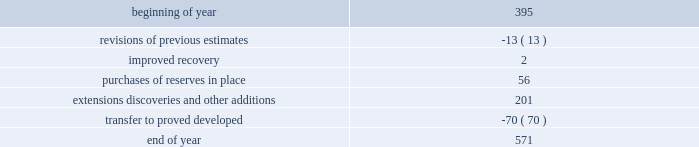Estimates of synthetic crude oil reserves are prepared by glj petroleum consultants of calgary , canada , third-party consultants .
Their reports for all years are filed as exhibits to this annual report on form 10-k .
The team lead responsible for the estimates of our osm reserves has 34 years of experience in petroleum engineering and has conducted surface mineable oil sands evaluations since 1986 .
He is a member of spe , having served as regional director from 1998 through 2001 .
The second team member has 13 years of experience in petroleum engineering and has conducted surface mineable oil sands evaluations since 2009 .
Both are registered practicing professional engineers in the province of alberta .
Audits of estimates third-party consultants are engaged to provide independent estimates for fields that comprise 80 percent of our total proved reserves over a rolling four-year period for the purpose of auditing the in-house reserve estimates .
We met this goal for the four- year period ended december 31 , 2012 .
We established a tolerance level of 10 percent such that initial estimates by the third-party consultants are accepted if they are within 10 percent of our internal estimates .
Should the third-party consultants 2019 initial analysis fail to reach our tolerance level , both our team and the consultants re-examine the information provided , request additional data and refine their analysis if appropriate .
This resolution process is continued until both estimates are within 10 percent .
In the very limited instances where differences outside the 10 percent tolerance cannot be resolved by year end , a plan to resolve the difference is developed and our senior management is informed .
This process did not result in significant changes to our reserve estimates in 2012 or 2011 .
There were no third-party audits performed in 2010 .
During 2012 , netherland , sewell & associates , inc .
( "nsai" ) prepared a certification of december 31 , 2011 reserves for the alba field in e.g .
The nsai summary report is filed as an exhibit to this annual report on form 10-k .
Members of the nsai team have many years of industry experience , having worked for large , international oil and gas companies before joining nsai .
The senior technical advisor has a bachelor of science degree in geophysics and over 15 years of experience in the estimation of and evaluation of reserves .
The second member has a bachelor of science degree in chemical engineering and master of business administration along with over 3 years of experience in estimation and evaluation of reserves .
Both are licensed in the state of texas .
Ryder scott company ( "ryder scott" ) performed audits of several of our fields in 2012 and 2011 .
Their summary reports on audits performed in 2012 and 2011 are filed as exhibits to this annual report on form 10-k .
The team lead for ryder scott has over 20 years of industry experience , having worked for a major international oil and gas company before joining ryder scott .
He has a bachelor of science degree in mechanical engineering , is a member of spe where he served on the oil and gas reserves committee and is a registered professional engineer in the state of texas .
Changes in proved undeveloped reserves as of december 31 , 2012 , 571 mmboe of proved undeveloped reserves were reported , an increase of 176 mmboe from december 31 , 2011 .
The table shows changes in total proved undeveloped reserves for 2012 : ( mmboe ) .
Significant additions to proved undeveloped reserves during 2012 include 56 mmboe due to acquisitions in the eagle ford shale .
Development drilling added 124 mmboe in the eagle ford , 35 mmboe in the bakken and 15 mmboe in the oklahoma resource basins shale play .
A gas sharing agreement signed with the libyan government in 2012 added 19 mmboe .
Additionally , 30 mmboe were transferred from proved undeveloped to proved developed reserves in the eagle ford and 14 mmboe in the bakken shale plays due to producing wells .
Costs incurred in 2012 , 2011 and 2010 relating to the development of proved undeveloped reserves , were $ 1995 million $ 1107 million and $ 1463 million .
A total of 27 mmboe was booked as a result of reliable technology .
Technologies included statistical analysis of production performance , decline curve analysis , rate transient analysis , reservoir simulation and volumetric analysis .
The statistical nature of production performance coupled with highly certain reservoir continuity or quality within the reliable technology areas and sufficient proved undeveloped locations establish the reasonable certainty criteria required for booking reserves. .
By how much did undeveloped reserves increase during 2012? 
Computations: ((571 - 395) / 395)
Answer: 0.44557. Estimates of synthetic crude oil reserves are prepared by glj petroleum consultants of calgary , canada , third-party consultants .
Their reports for all years are filed as exhibits to this annual report on form 10-k .
The team lead responsible for the estimates of our osm reserves has 34 years of experience in petroleum engineering and has conducted surface mineable oil sands evaluations since 1986 .
He is a member of spe , having served as regional director from 1998 through 2001 .
The second team member has 13 years of experience in petroleum engineering and has conducted surface mineable oil sands evaluations since 2009 .
Both are registered practicing professional engineers in the province of alberta .
Audits of estimates third-party consultants are engaged to provide independent estimates for fields that comprise 80 percent of our total proved reserves over a rolling four-year period for the purpose of auditing the in-house reserve estimates .
We met this goal for the four- year period ended december 31 , 2012 .
We established a tolerance level of 10 percent such that initial estimates by the third-party consultants are accepted if they are within 10 percent of our internal estimates .
Should the third-party consultants 2019 initial analysis fail to reach our tolerance level , both our team and the consultants re-examine the information provided , request additional data and refine their analysis if appropriate .
This resolution process is continued until both estimates are within 10 percent .
In the very limited instances where differences outside the 10 percent tolerance cannot be resolved by year end , a plan to resolve the difference is developed and our senior management is informed .
This process did not result in significant changes to our reserve estimates in 2012 or 2011 .
There were no third-party audits performed in 2010 .
During 2012 , netherland , sewell & associates , inc .
( "nsai" ) prepared a certification of december 31 , 2011 reserves for the alba field in e.g .
The nsai summary report is filed as an exhibit to this annual report on form 10-k .
Members of the nsai team have many years of industry experience , having worked for large , international oil and gas companies before joining nsai .
The senior technical advisor has a bachelor of science degree in geophysics and over 15 years of experience in the estimation of and evaluation of reserves .
The second member has a bachelor of science degree in chemical engineering and master of business administration along with over 3 years of experience in estimation and evaluation of reserves .
Both are licensed in the state of texas .
Ryder scott company ( "ryder scott" ) performed audits of several of our fields in 2012 and 2011 .
Their summary reports on audits performed in 2012 and 2011 are filed as exhibits to this annual report on form 10-k .
The team lead for ryder scott has over 20 years of industry experience , having worked for a major international oil and gas company before joining ryder scott .
He has a bachelor of science degree in mechanical engineering , is a member of spe where he served on the oil and gas reserves committee and is a registered professional engineer in the state of texas .
Changes in proved undeveloped reserves as of december 31 , 2012 , 571 mmboe of proved undeveloped reserves were reported , an increase of 176 mmboe from december 31 , 2011 .
The table shows changes in total proved undeveloped reserves for 2012 : ( mmboe ) .
Significant additions to proved undeveloped reserves during 2012 include 56 mmboe due to acquisitions in the eagle ford shale .
Development drilling added 124 mmboe in the eagle ford , 35 mmboe in the bakken and 15 mmboe in the oklahoma resource basins shale play .
A gas sharing agreement signed with the libyan government in 2012 added 19 mmboe .
Additionally , 30 mmboe were transferred from proved undeveloped to proved developed reserves in the eagle ford and 14 mmboe in the bakken shale plays due to producing wells .
Costs incurred in 2012 , 2011 and 2010 relating to the development of proved undeveloped reserves , were $ 1995 million $ 1107 million and $ 1463 million .
A total of 27 mmboe was booked as a result of reliable technology .
Technologies included statistical analysis of production performance , decline curve analysis , rate transient analysis , reservoir simulation and volumetric analysis .
The statistical nature of production performance coupled with highly certain reservoir continuity or quality within the reliable technology areas and sufficient proved undeveloped locations establish the reasonable certainty criteria required for booking reserves. .
In mmboe what was the total of reserves transferred from proved undeveloped to proved developed reserves in the eagle ford and in the bakken shale plays? 
Computations: (30 + 14)
Answer: 44.0. 